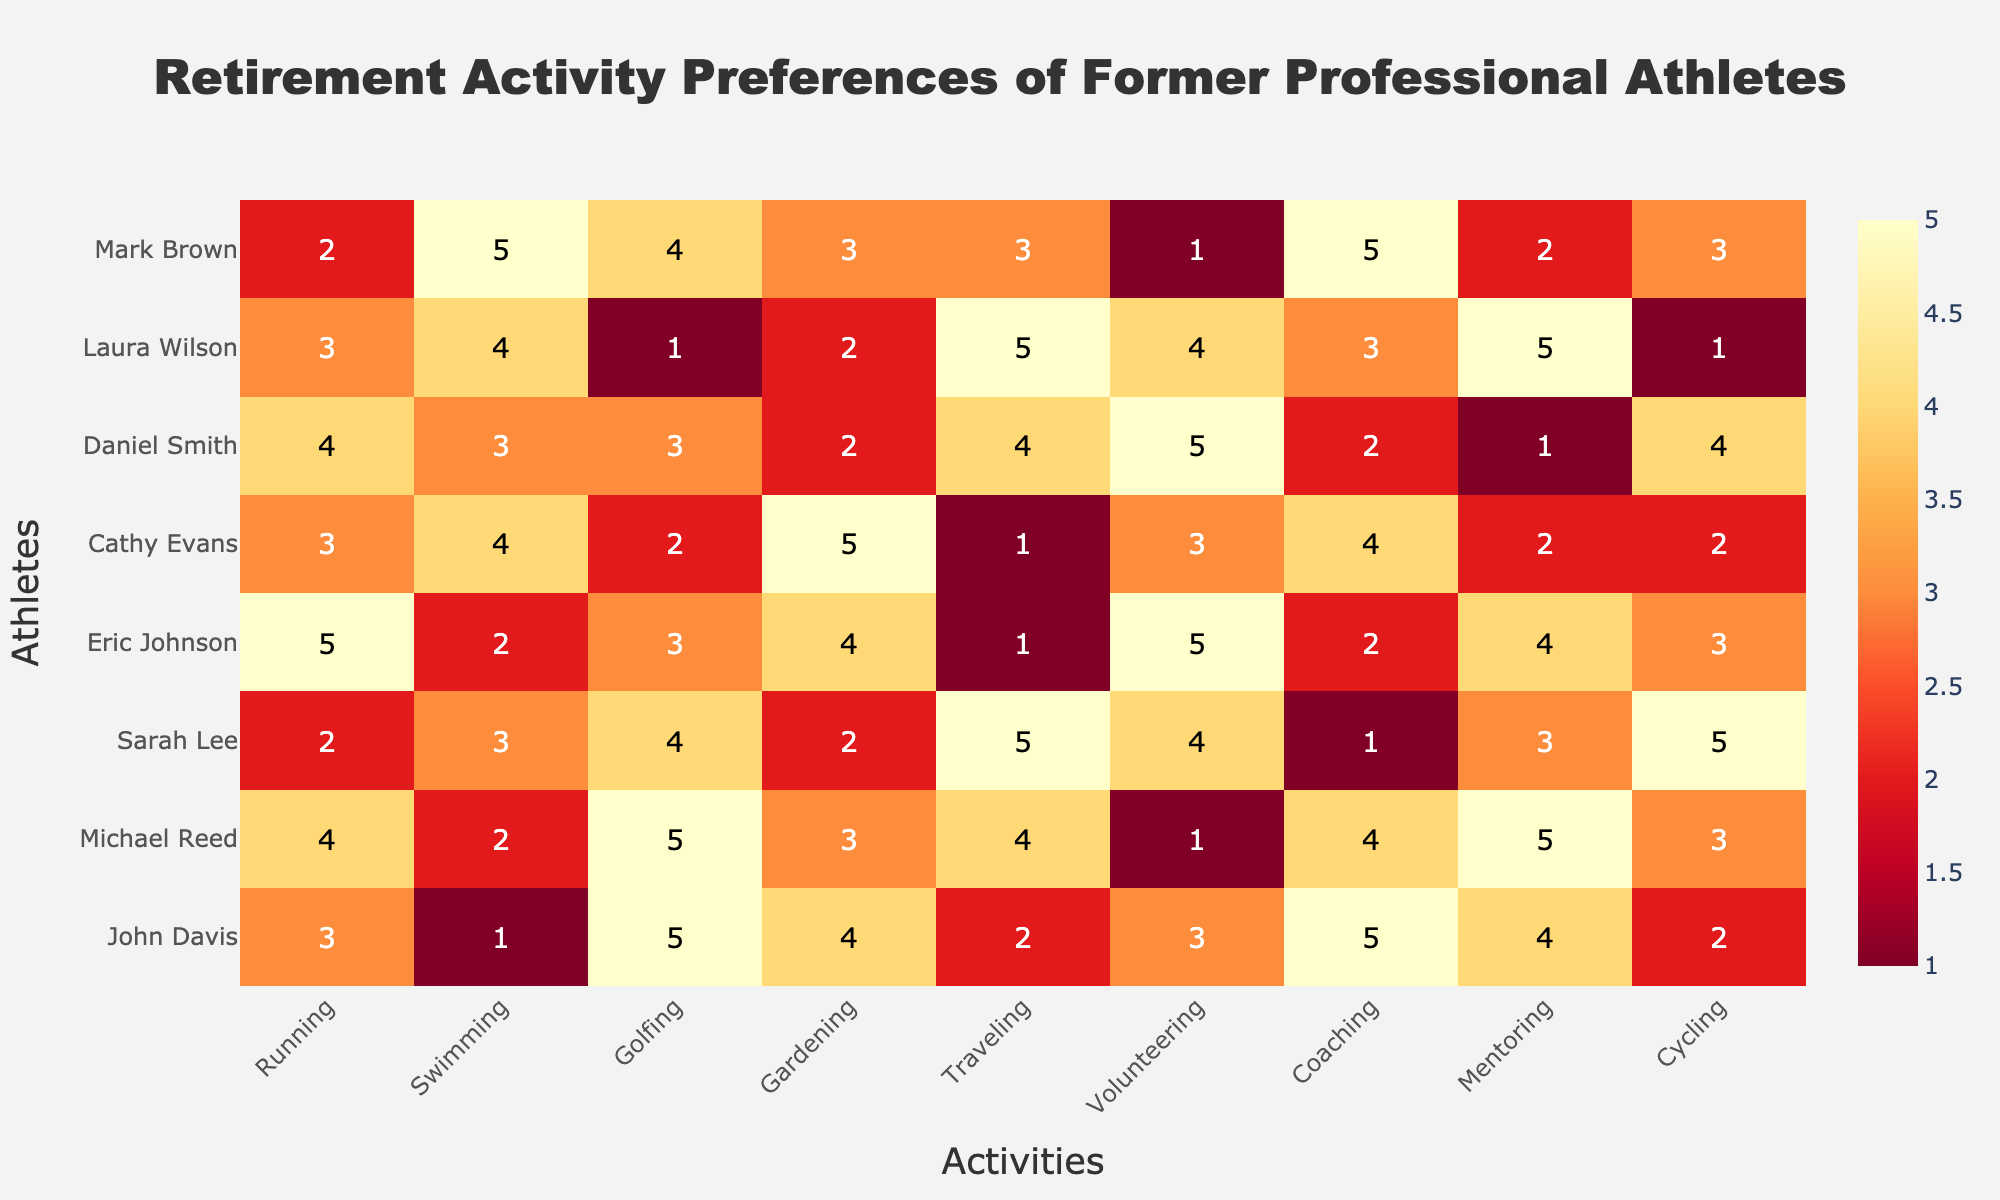What activity does John Davis prefer the most? In the heatmap, we look at the row corresponding to John Davis and identify the activity with the highest value. John Davis has the highest score of 5 for Golfing and Coaching.
Answer: Golfing, Coaching Which athlete has the least preference for Traveling? To find this, we look at the column labeled 'Traveling' and identify the athlete with the lowest value. The lowest preference for Traveling is 1, which is given by Eric Johnson and Cathy Evans.
Answer: Eric Johnson, Cathy Evans What's the median value of preferences for Golfing among all athletes? First, list all the values for Golfing: 5, 5, 4, 3, 2, 3, 1, 4. Arrange these values in ascending order: 1, 2, 3, 3, 4, 4, 5, 5. The median is the average of the 4th and 5th values in this sorted list, which are both 3 and 4. Therefore, (3+4)/2 = 3.5.
Answer: 3.5 Which athlete enjoys Volunteering the most? To determine this, examine the 'Volunteering' column and find the athlete with the highest value. Daniel Smith has the highest preference for Volunteering with a score of 5.
Answer: Daniel Smith Compare Sarah Lee's and Michael Reed's preferences for Running. Who prefers it more? Look at the 'Running' column for both Sarah Lee and Michael Reed. Sarah Lee's preference score is 2, while Michael Reed's is 4. Therefore, Michael Reed prefers Running more.
Answer: Michael Reed Calculate the average preference score for Gardening among all athletes. Sum the scores for Gardening: 4, 3, 2, 4, 5, 2, 2, 3. The total is 25. There are 8 athletes, so the average score is 25/8 = 3.125.
Answer: 3.125 Does any athlete have the same preference score for Coaching and Mentoring? Compare the Coaching and Mentoring columns for each athlete. John Davis (5, 4), Michael Reed (4, 5), Sarah Lee (1, 3), Eric Johnson (2, 4), Cathy Evans (4, 2), Daniel Smith (2, 1), Laura Wilson (3, 5), Mark Brown (5, 2). None of the athletes have the same scores for Coaching and Mentoring.
Answer: No 